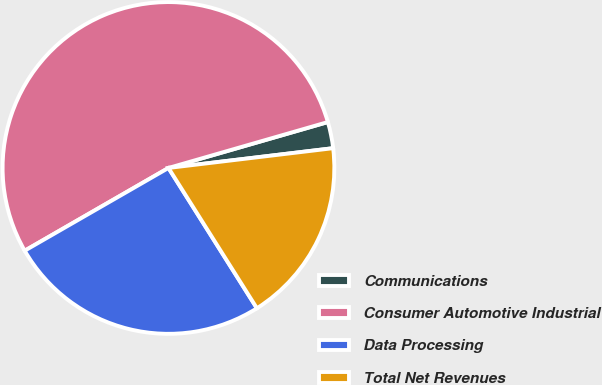<chart> <loc_0><loc_0><loc_500><loc_500><pie_chart><fcel>Communications<fcel>Consumer Automotive Industrial<fcel>Data Processing<fcel>Total Net Revenues<nl><fcel>2.56%<fcel>53.85%<fcel>25.64%<fcel>17.95%<nl></chart> 